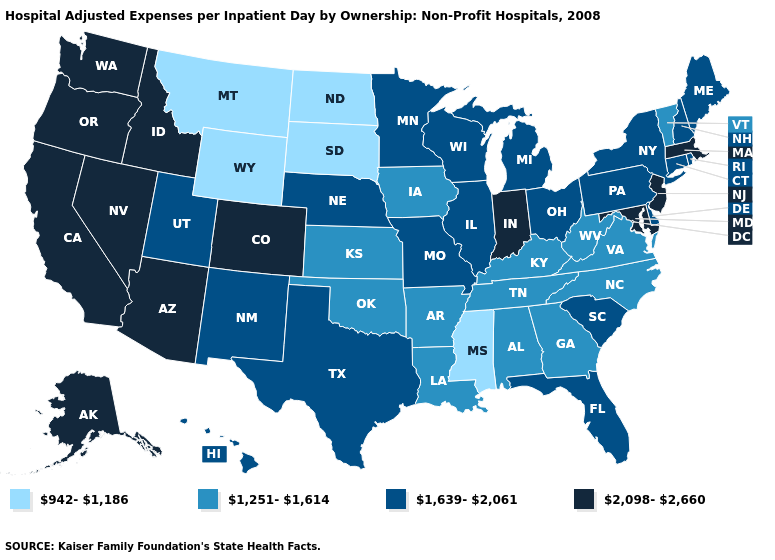Name the states that have a value in the range 1,639-2,061?
Be succinct. Connecticut, Delaware, Florida, Hawaii, Illinois, Maine, Michigan, Minnesota, Missouri, Nebraska, New Hampshire, New Mexico, New York, Ohio, Pennsylvania, Rhode Island, South Carolina, Texas, Utah, Wisconsin. Among the states that border Massachusetts , which have the highest value?
Give a very brief answer. Connecticut, New Hampshire, New York, Rhode Island. Does the map have missing data?
Be succinct. No. Does the map have missing data?
Be succinct. No. Does South Carolina have the highest value in the South?
Keep it brief. No. What is the highest value in states that border Ohio?
Short answer required. 2,098-2,660. Name the states that have a value in the range 2,098-2,660?
Write a very short answer. Alaska, Arizona, California, Colorado, Idaho, Indiana, Maryland, Massachusetts, Nevada, New Jersey, Oregon, Washington. What is the lowest value in states that border Georgia?
Answer briefly. 1,251-1,614. Does West Virginia have the lowest value in the South?
Answer briefly. No. Is the legend a continuous bar?
Quick response, please. No. Is the legend a continuous bar?
Keep it brief. No. Which states hav the highest value in the Northeast?
Keep it brief. Massachusetts, New Jersey. Does Indiana have the highest value in the USA?
Give a very brief answer. Yes. Among the states that border Texas , does Arkansas have the lowest value?
Quick response, please. Yes. 